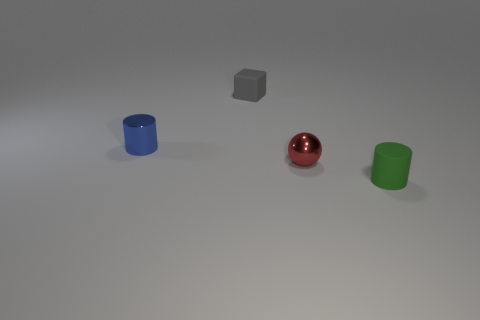Add 1 tiny red shiny objects. How many objects exist? 5 Subtract 1 cylinders. How many cylinders are left? 1 Subtract all balls. How many objects are left? 3 Subtract 0 yellow spheres. How many objects are left? 4 Subtract all large blue matte cubes. Subtract all green things. How many objects are left? 3 Add 1 blue metal things. How many blue metal things are left? 2 Add 4 yellow matte spheres. How many yellow matte spheres exist? 4 